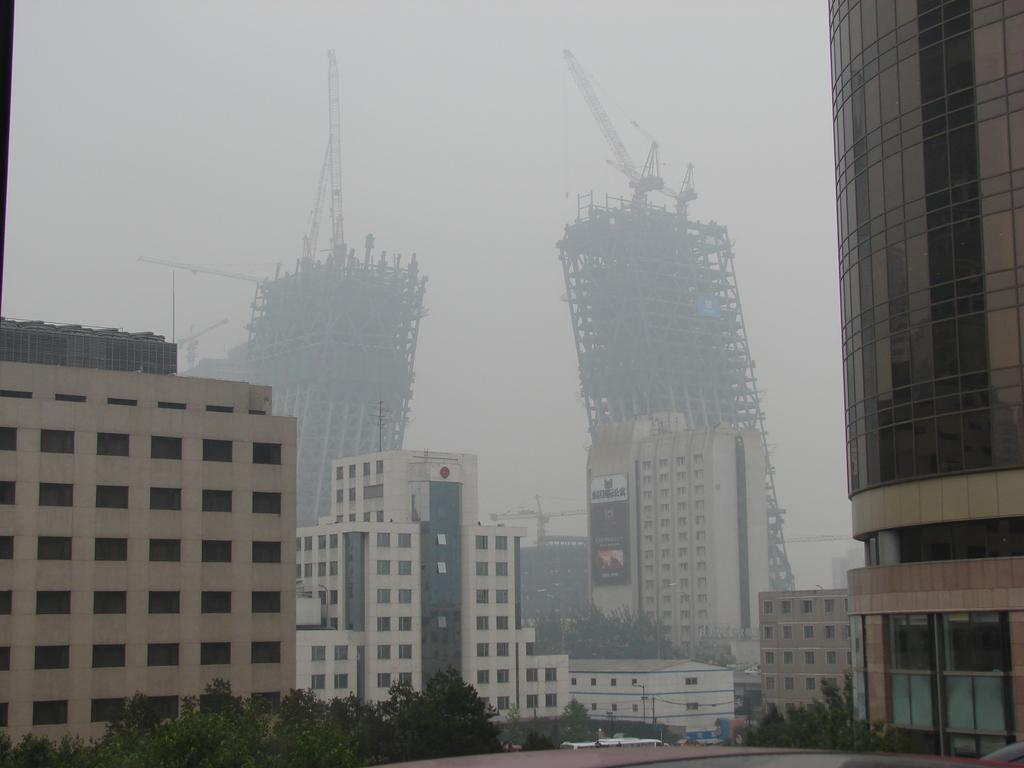What type of structures can be seen in the image? There are buildings in the image. Can you describe the condition of the buildings in the background? Two buildings in the background appear to be falling. What type of club is located downtown in the image? There is no club or downtown location mentioned in the image; it only features buildings, including two that appear to be falling. 